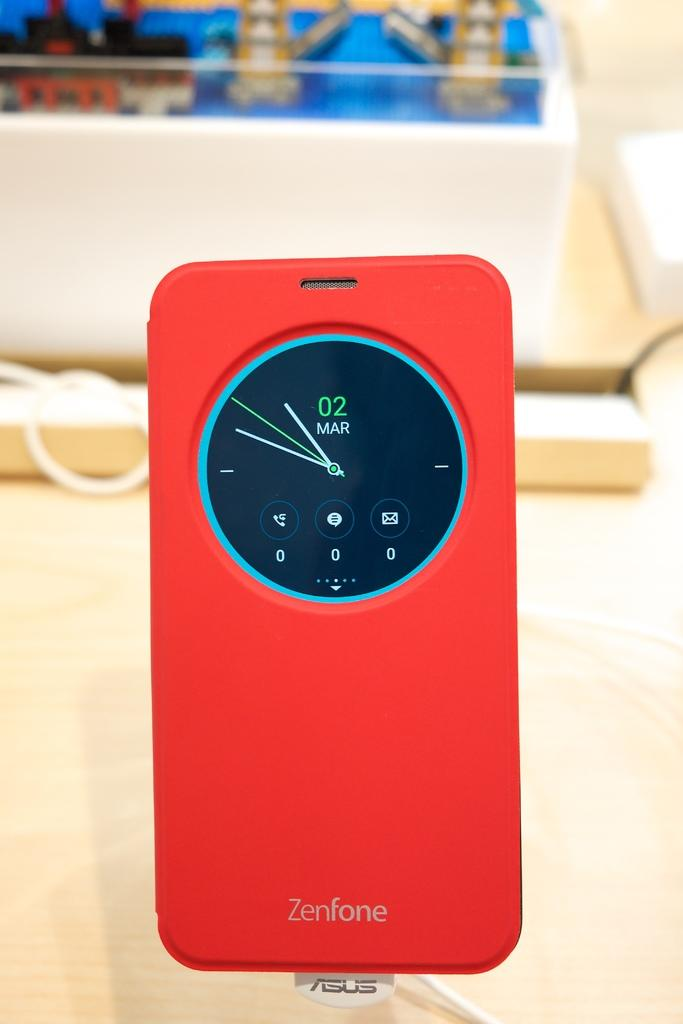<image>
Render a clear and concise summary of the photo. A red Zenfone shows that the date is March 2. 